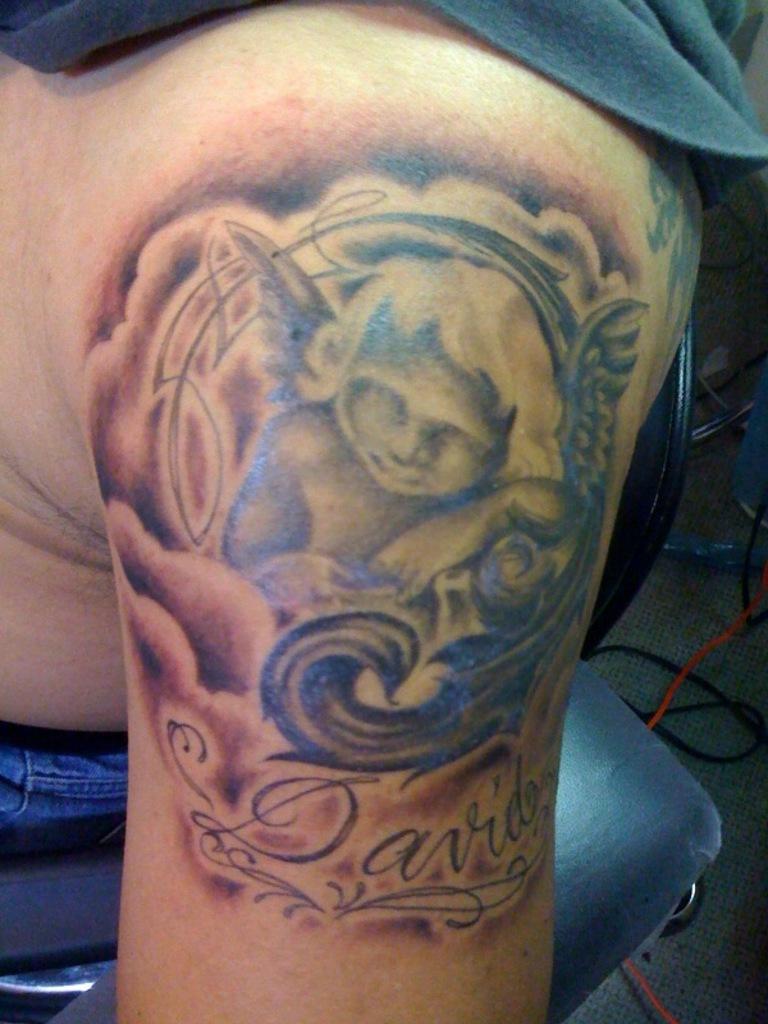Describe this image in one or two sentences. It is a tattoo of a baby on the human skin. 